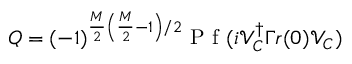<formula> <loc_0><loc_0><loc_500><loc_500>Q = ( - 1 ) ^ { \frac { M } { 2 } \left ( \frac { M } { 2 } - 1 \right ) / 2 } P f ( i \mathcal { V } _ { C } ^ { \dagger } \Gamma r ( 0 ) \mathcal { V } _ { C } )</formula> 